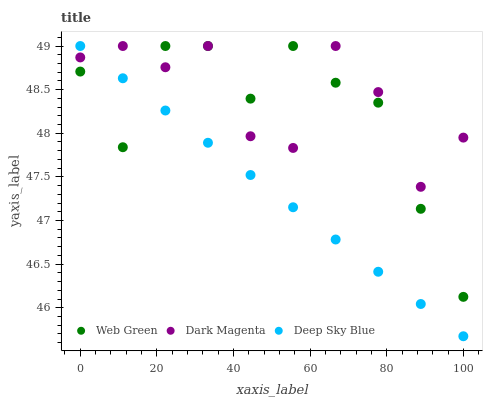Does Deep Sky Blue have the minimum area under the curve?
Answer yes or no. Yes. Does Dark Magenta have the maximum area under the curve?
Answer yes or no. Yes. Does Web Green have the minimum area under the curve?
Answer yes or no. No. Does Web Green have the maximum area under the curve?
Answer yes or no. No. Is Deep Sky Blue the smoothest?
Answer yes or no. Yes. Is Dark Magenta the roughest?
Answer yes or no. Yes. Is Web Green the smoothest?
Answer yes or no. No. Is Web Green the roughest?
Answer yes or no. No. Does Deep Sky Blue have the lowest value?
Answer yes or no. Yes. Does Web Green have the lowest value?
Answer yes or no. No. Does Web Green have the highest value?
Answer yes or no. Yes. Does Deep Sky Blue intersect Dark Magenta?
Answer yes or no. Yes. Is Deep Sky Blue less than Dark Magenta?
Answer yes or no. No. Is Deep Sky Blue greater than Dark Magenta?
Answer yes or no. No. 